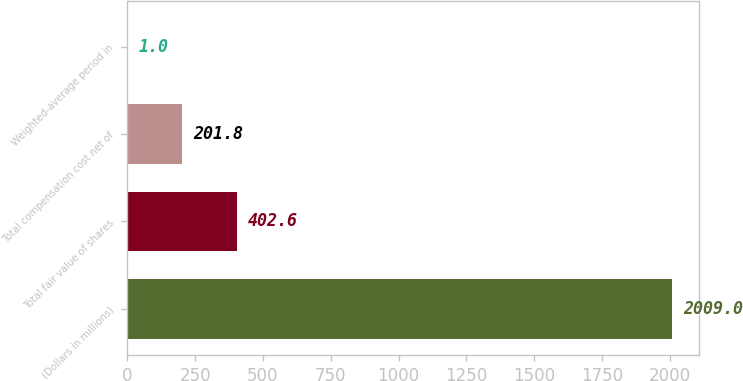Convert chart. <chart><loc_0><loc_0><loc_500><loc_500><bar_chart><fcel>(Dollars in millions)<fcel>Total fair value of shares<fcel>Total compensation cost net of<fcel>Weighted-average period in<nl><fcel>2009<fcel>402.6<fcel>201.8<fcel>1<nl></chart> 